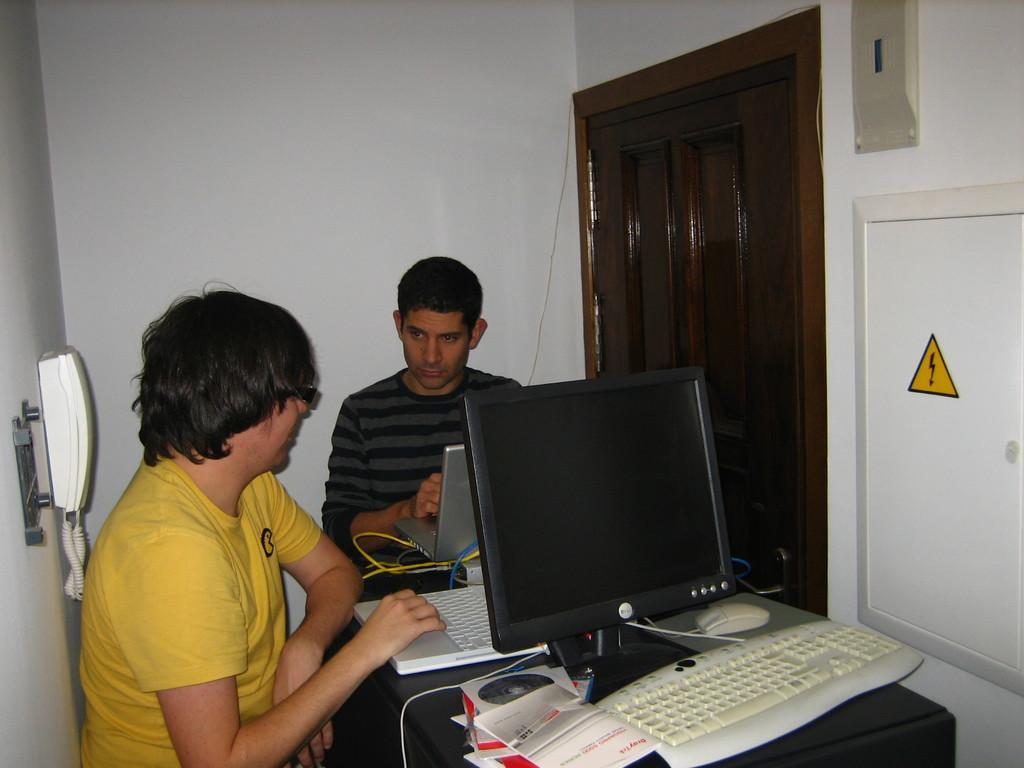Describe this image in one or two sentences. in a room there is a table in the center on which there is white keyboard, white mouse, 2 laptops. 2 people are seated around it. the person at the left is wearing a yellow t shirt and operating a white laptop. the at the back is wearing a black t shirt and operating a grey laptop. at the left, on the wall there is a white telephone. the wall is white in color. at the right there is a wooden door. 